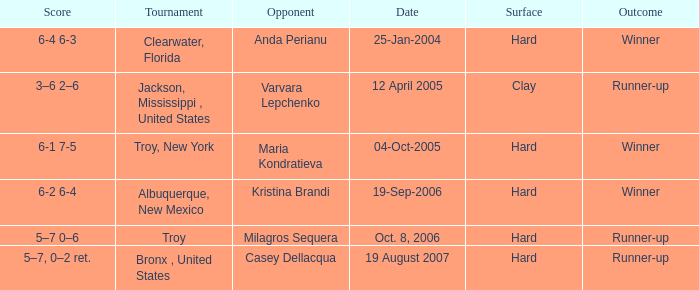What was the surface of the game that resulted in a final score of 6-1 7-5? Hard. 